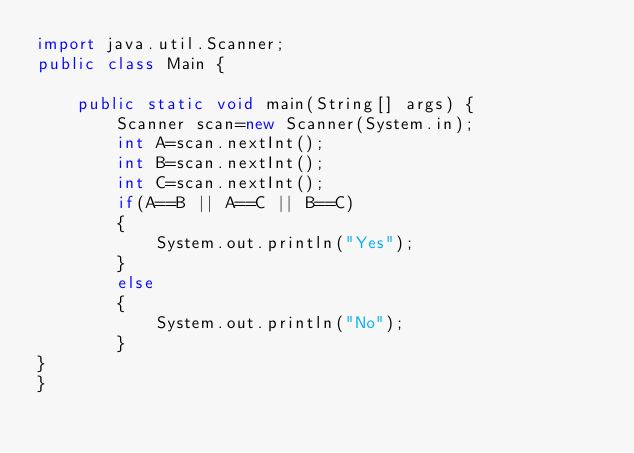<code> <loc_0><loc_0><loc_500><loc_500><_Java_>import java.util.Scanner;
public class Main {

	public static void main(String[] args) {
		Scanner scan=new Scanner(System.in);
		int A=scan.nextInt();
		int B=scan.nextInt();
		int C=scan.nextInt();
		if(A==B || A==C || B==C)
		{
			System.out.println("Yes");
		}
		else
		{
			System.out.println("No");
		}
}
}
</code> 